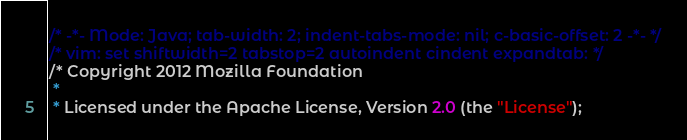Convert code to text. <code><loc_0><loc_0><loc_500><loc_500><_JavaScript_>/* -*- Mode: Java; tab-width: 2; indent-tabs-mode: nil; c-basic-offset: 2 -*- */
/* vim: set shiftwidth=2 tabstop=2 autoindent cindent expandtab: */
/* Copyright 2012 Mozilla Foundation
 *
 * Licensed under the Apache License, Version 2.0 (the "License");</code> 